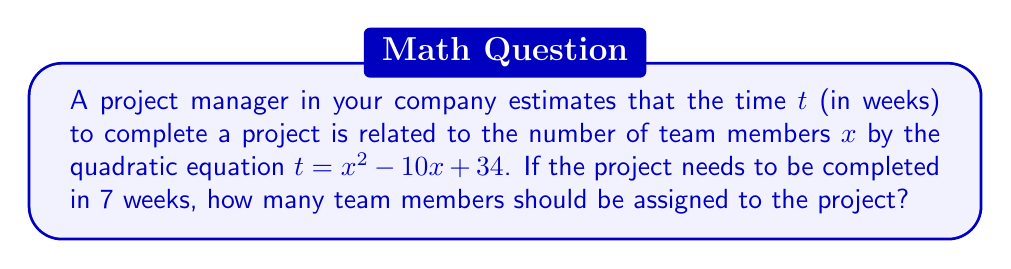What is the answer to this math problem? To solve this problem, we need to follow these steps:

1) We're given the quadratic equation: $t = x^2 - 10x + 34$

2) We want to find $x$ when $t = 7$. So, we substitute $t = 7$ into the equation:

   $7 = x^2 - 10x + 34$

3) Rearrange the equation to standard form $(ax^2 + bx + c = 0)$:

   $x^2 - 10x + 27 = 0$

4) We can solve this using the quadratic formula: $x = \frac{-b \pm \sqrt{b^2 - 4ac}}{2a}$

   Where $a = 1$, $b = -10$, and $c = 27$

5) Substituting these values into the quadratic formula:

   $x = \frac{10 \pm \sqrt{(-10)^2 - 4(1)(27)}}{2(1)}$

6) Simplify:

   $x = \frac{10 \pm \sqrt{100 - 108}}{2} = \frac{10 \pm \sqrt{-8}}{2}$

7) Since we can't have a negative number under the square root in real solutions, there is no real solution to this equation.

8) This means that it's not possible to complete the project in exactly 7 weeks with any number of team members using this model.

9) To find the minimum completion time, we can find the vertex of the parabola:

   $x = -\frac{b}{2a} = -\frac{-10}{2(1)} = 5$

   The minimum time is: $t = 5^2 - 10(5) + 34 = 25 - 50 + 34 = 9$ weeks

Therefore, the minimum completion time according to this model is 9 weeks with 5 team members.
Answer: Not possible in 7 weeks. Minimum time is 9 weeks with 5 team members. 